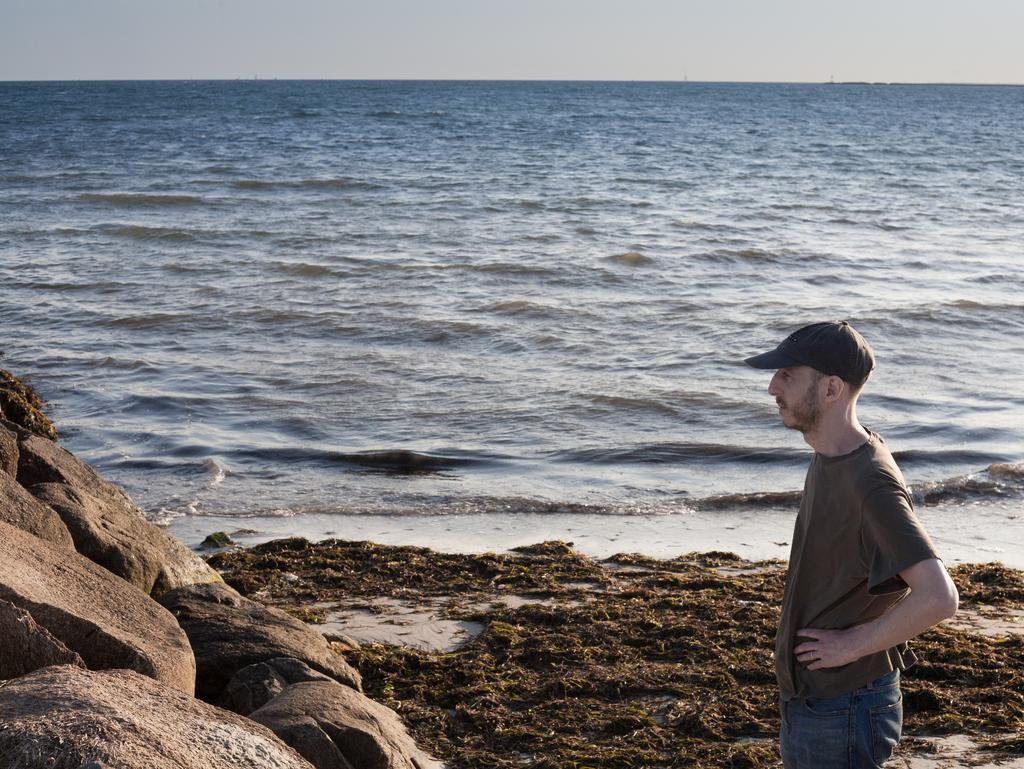What is the person in the image wearing on their head? The person in the image is wearing a cap. What is the person's posture in the image? The person is standing in the image. What type of surface is visible beneath the person? There is ground visible in the image. What objects can be seen on the ground in the image? There are objects on the ground in the image. What can be found on the left side of the image? There are stones on the left side of the image. What natural element is visible in the image? There is water visible in the image. What part of the environment is visible above the person? The sky is visible in the image. What type of church can be seen on the island in the image? There is no island or church present in the image. What type of camp is set up near the water in the image? There is no camp present in the image. 